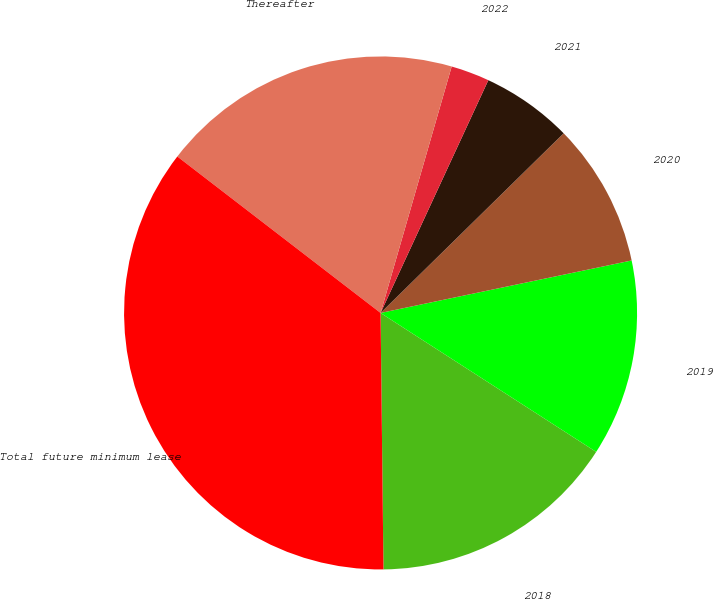Convert chart to OTSL. <chart><loc_0><loc_0><loc_500><loc_500><pie_chart><fcel>2018<fcel>2019<fcel>2020<fcel>2021<fcel>2022<fcel>Thereafter<fcel>Total future minimum lease<nl><fcel>15.71%<fcel>12.39%<fcel>9.07%<fcel>5.75%<fcel>2.43%<fcel>19.03%<fcel>35.62%<nl></chart> 